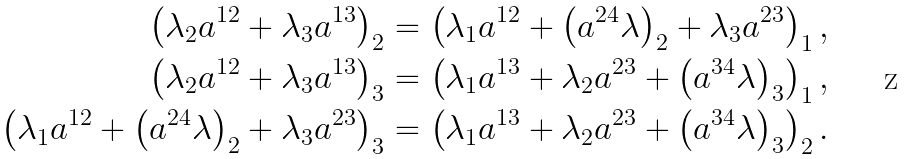<formula> <loc_0><loc_0><loc_500><loc_500>\left ( \lambda _ { 2 } a ^ { 1 2 } + \lambda _ { 3 } a ^ { 1 3 } \right ) _ { 2 } = \left ( \lambda _ { 1 } a ^ { 1 2 } + \left ( a ^ { 2 4 } \lambda \right ) _ { 2 } + \lambda _ { 3 } a ^ { 2 3 } \right ) _ { 1 } , \\ \left ( \lambda _ { 2 } a ^ { 1 2 } + \lambda _ { 3 } a ^ { 1 3 } \right ) _ { 3 } = \left ( \lambda _ { 1 } a ^ { 1 3 } + \lambda _ { 2 } a ^ { 2 3 } + \left ( a ^ { 3 4 } \lambda \right ) _ { 3 } \right ) _ { 1 } , \\ \left ( \lambda _ { 1 } a ^ { 1 2 } + \left ( a ^ { 2 4 } \lambda \right ) _ { 2 } + \lambda _ { 3 } a ^ { 2 3 } \right ) _ { 3 } = \left ( \lambda _ { 1 } a ^ { 1 3 } + \lambda _ { 2 } a ^ { 2 3 } + \left ( a ^ { 3 4 } \lambda \right ) _ { 3 } \right ) _ { 2 } .</formula> 